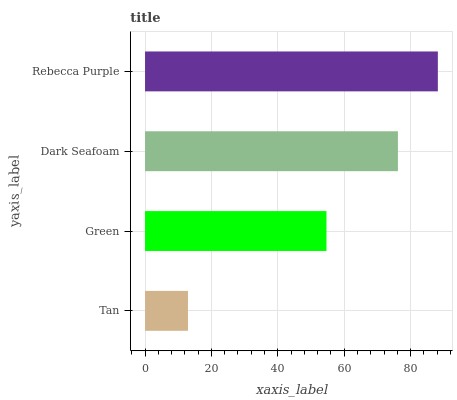Is Tan the minimum?
Answer yes or no. Yes. Is Rebecca Purple the maximum?
Answer yes or no. Yes. Is Green the minimum?
Answer yes or no. No. Is Green the maximum?
Answer yes or no. No. Is Green greater than Tan?
Answer yes or no. Yes. Is Tan less than Green?
Answer yes or no. Yes. Is Tan greater than Green?
Answer yes or no. No. Is Green less than Tan?
Answer yes or no. No. Is Dark Seafoam the high median?
Answer yes or no. Yes. Is Green the low median?
Answer yes or no. Yes. Is Rebecca Purple the high median?
Answer yes or no. No. Is Rebecca Purple the low median?
Answer yes or no. No. 